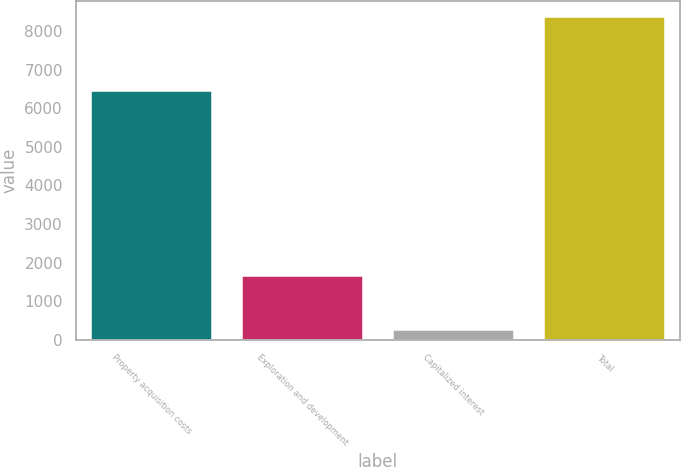<chart> <loc_0><loc_0><loc_500><loc_500><bar_chart><fcel>Property acquisition costs<fcel>Exploration and development<fcel>Capitalized interest<fcel>Total<nl><fcel>6437<fcel>1666<fcel>260<fcel>8363<nl></chart> 